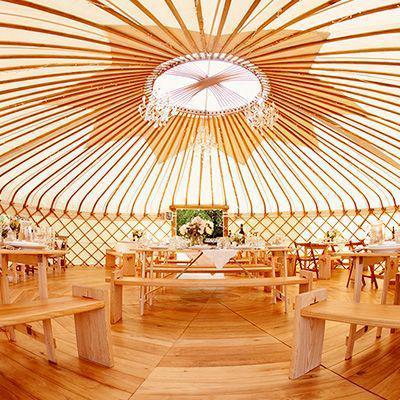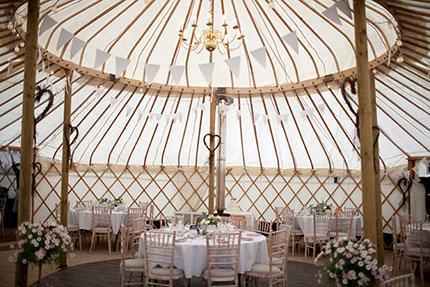The first image is the image on the left, the second image is the image on the right. Analyze the images presented: Is the assertion "there are benches at the tables in the image on the left" valid? Answer yes or no. Yes. The first image is the image on the left, the second image is the image on the right. Assess this claim about the two images: "There is one bed in the image on the right.". Correct or not? Answer yes or no. No. 